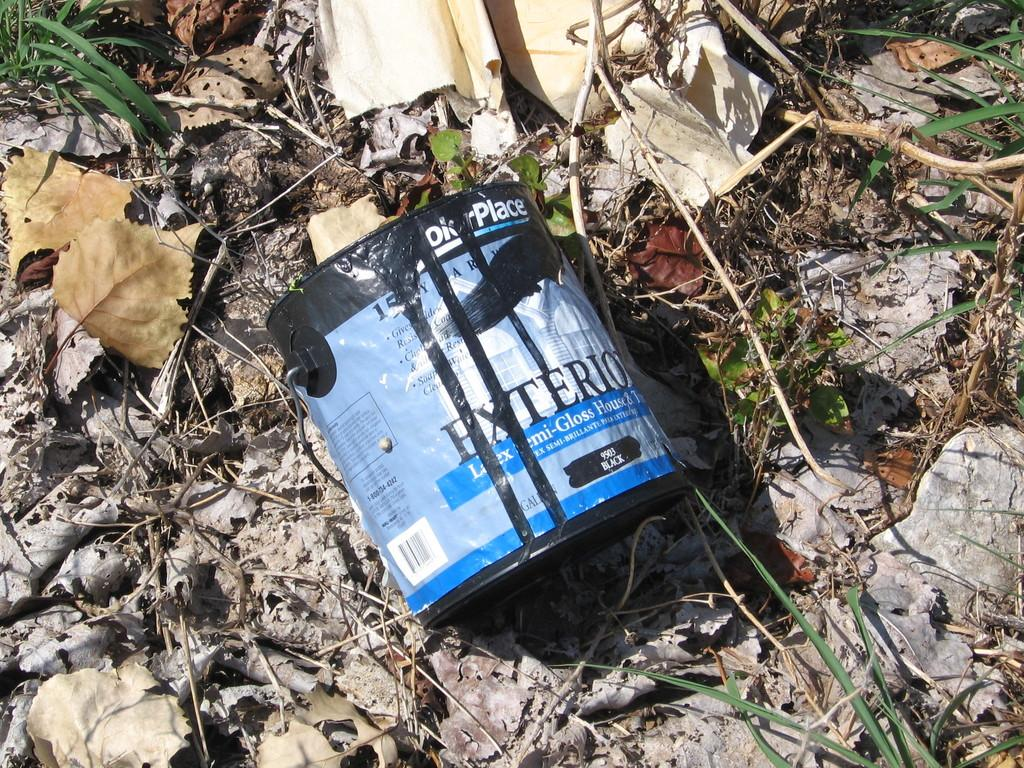What is the main object in the image? There is a tin in the image. What type of natural elements can be seen in the image? There are dried leaves, sticks, and grass in the image. Are there any objects on the ground in the image? Yes, there are objects on the ground in the image. What type of scarf is draped over the tin in the image? There is no scarf present in the image; it only features a tin, dried leaves, sticks, and grass. How many cakes are visible on the ground in the image? There are no cakes present in the image; it only features a tin, dried leaves, sticks, and grass. 